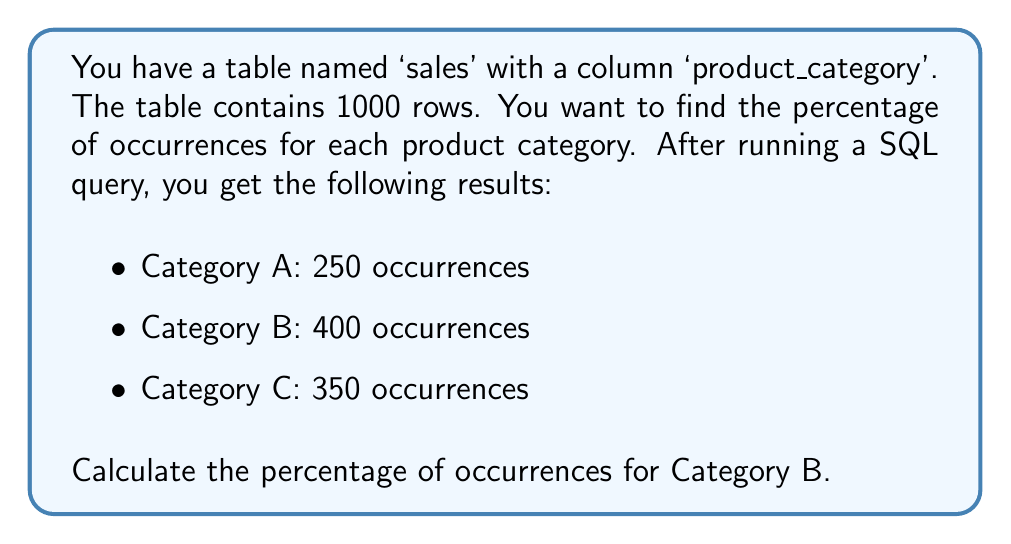Provide a solution to this math problem. To calculate the percentage of occurrences for Category B, we need to follow these steps:

1. Calculate the total number of occurrences:
   Total = 250 + 400 + 350 = 1000
   (This matches the given total number of rows)

2. Calculate the percentage using the formula:
   $$ \text{Percentage} = \frac{\text{Number of occurrences}}{\text{Total occurrences}} \times 100\% $$

3. For Category B:
   $$ \text{Percentage} = \frac{400}{1000} \times 100\% $$

4. Simplify the fraction:
   $$ \text{Percentage} = \frac{4}{10} \times 100\% $$

5. Perform the multiplication:
   $$ \text{Percentage} = 0.4 \times 100\% = 40\% $$

In SQL, you could achieve this result with a query like:

```sql
SELECT 
    product_category,
    COUNT(*) * 100.0 / (SELECT COUNT(*) FROM sales) AS percentage
FROM 
    sales
GROUP BY 
    product_category;
```

This query would return the percentage for all categories, including Category B.
Answer: The percentage of occurrences for Category B is 40%. 